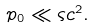Convert formula to latex. <formula><loc_0><loc_0><loc_500><loc_500>p _ { 0 } \ll \varsigma c ^ { 2 } .</formula> 